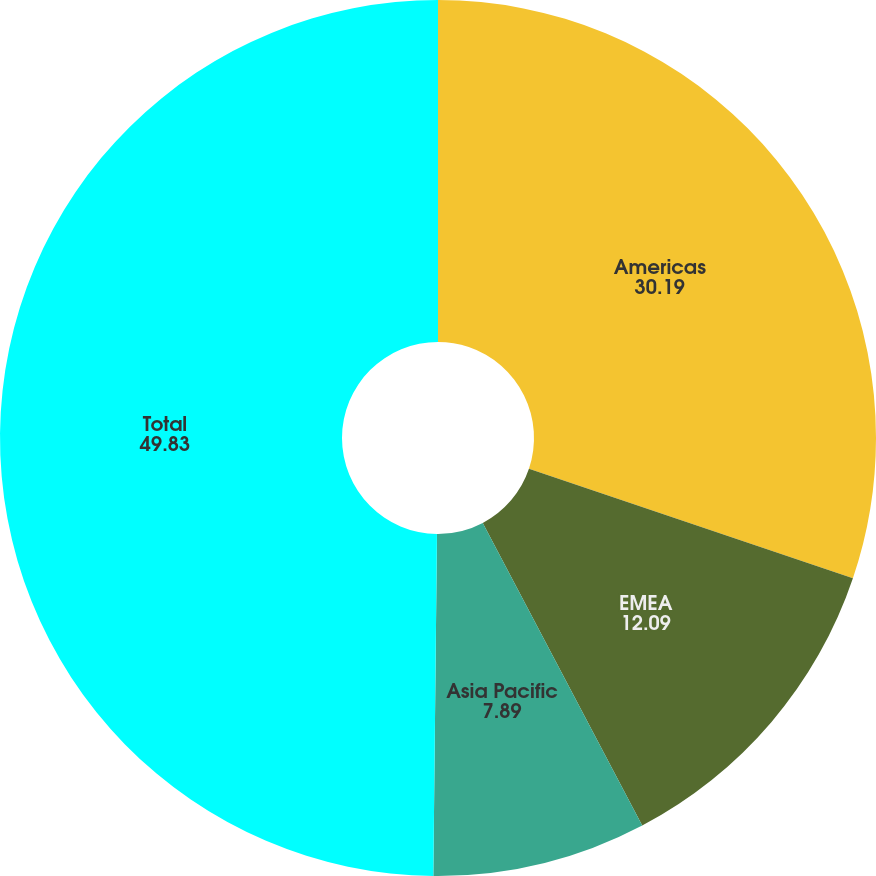<chart> <loc_0><loc_0><loc_500><loc_500><pie_chart><fcel>Americas<fcel>EMEA<fcel>Asia Pacific<fcel>Total<nl><fcel>30.19%<fcel>12.09%<fcel>7.89%<fcel>49.83%<nl></chart> 